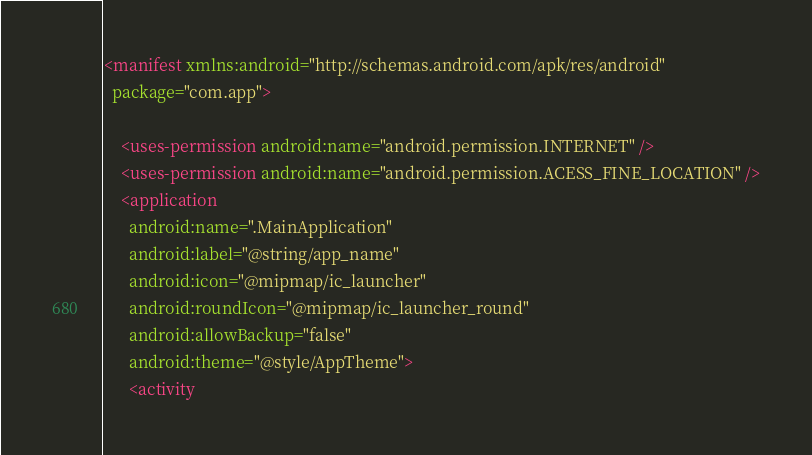Convert code to text. <code><loc_0><loc_0><loc_500><loc_500><_XML_><manifest xmlns:android="http://schemas.android.com/apk/res/android"
  package="com.app">

    <uses-permission android:name="android.permission.INTERNET" />
    <uses-permission android:name="android.permission.ACESS_FINE_LOCATION" />
    <application
      android:name=".MainApplication"
      android:label="@string/app_name"
      android:icon="@mipmap/ic_launcher"
      android:roundIcon="@mipmap/ic_launcher_round"
      android:allowBackup="false"
      android:theme="@style/AppTheme">
      <activity</code> 